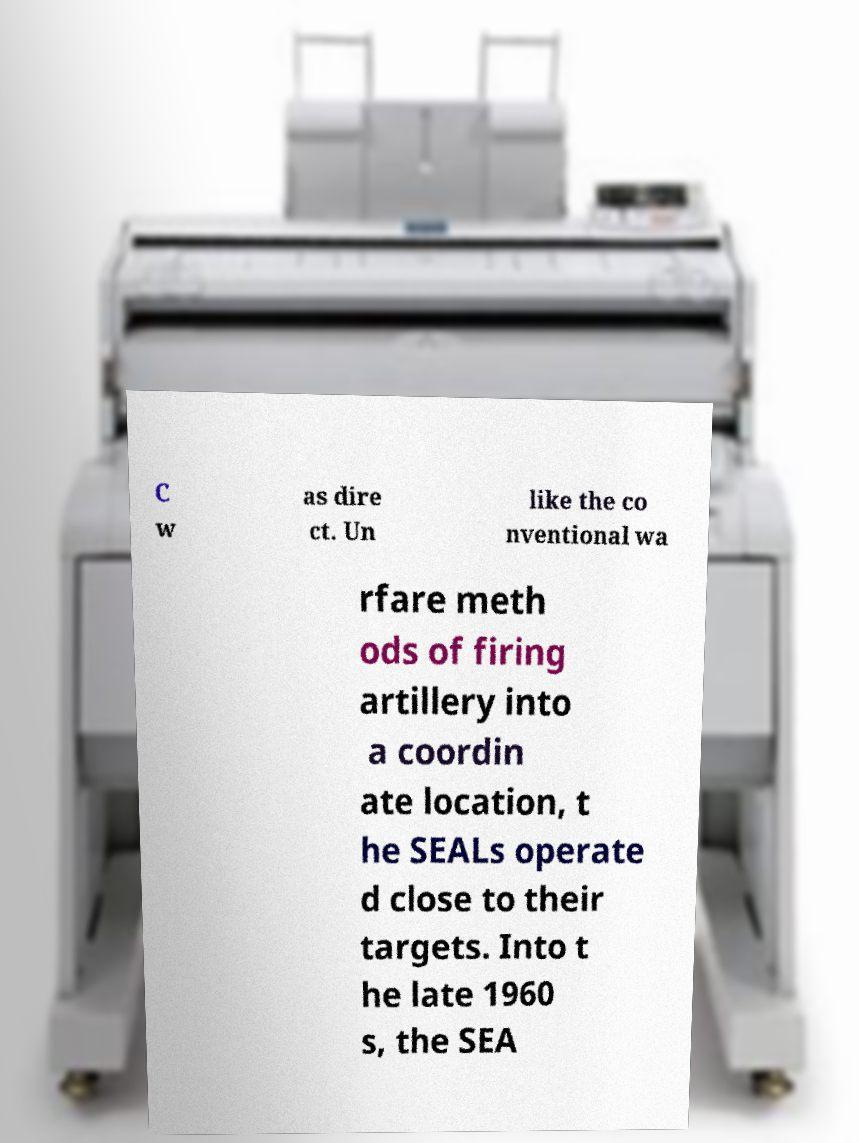I need the written content from this picture converted into text. Can you do that? C w as dire ct. Un like the co nventional wa rfare meth ods of firing artillery into a coordin ate location, t he SEALs operate d close to their targets. Into t he late 1960 s, the SEA 